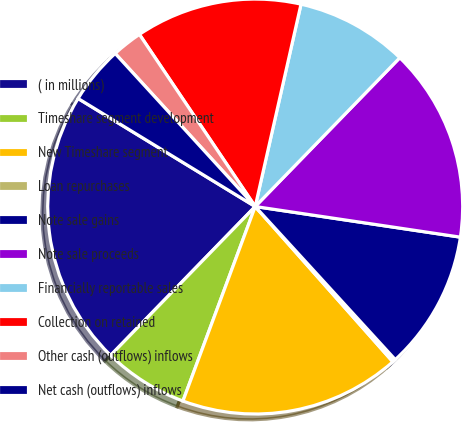Convert chart. <chart><loc_0><loc_0><loc_500><loc_500><pie_chart><fcel>( in millions)<fcel>Timeshare segment development<fcel>New Timeshare segment<fcel>Loan repurchases<fcel>Note sale gains<fcel>Note sale proceeds<fcel>Financially reportable sales<fcel>Collection on retained<fcel>Other cash (outflows) inflows<fcel>Net cash (outflows) inflows<nl><fcel>21.45%<fcel>6.61%<fcel>17.21%<fcel>0.25%<fcel>10.85%<fcel>15.09%<fcel>8.73%<fcel>12.97%<fcel>2.37%<fcel>4.49%<nl></chart> 